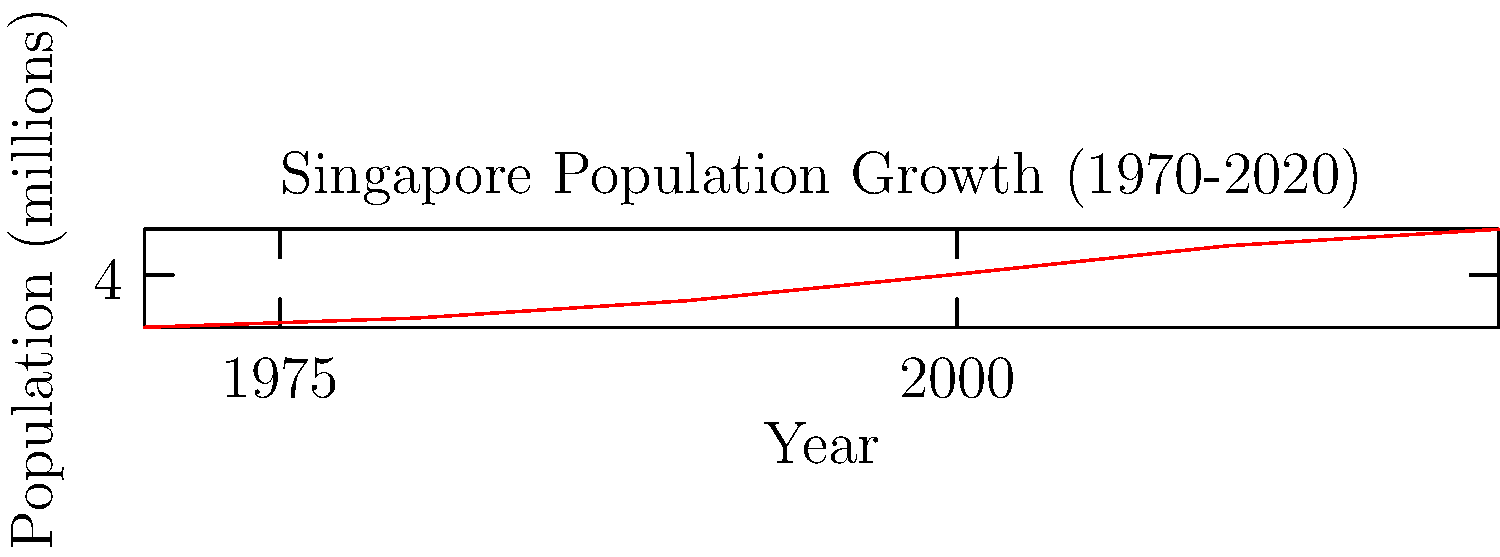Looking at the graph of Singapore's population growth from 1970 to 2020, in which decade did the population increase most rapidly? How does this relate to your experience living in Queenstown during that time? To determine the decade with the most rapid population growth, we need to calculate the population increase for each decade and compare:

1. 1970-1980: 2.41 - 2.07 = 0.34 million
2. 1980-1990: 3.05 - 2.41 = 0.64 million
3. 1990-2000: 4.03 - 3.05 = 0.98 million
4. 2000-2010: 5.08 - 4.03 = 1.05 million
5. 2010-2020: 5.69 - 5.08 = 0.61 million

The largest increase occurred between 2000 and 2010, with a growth of 1.05 million people.

For a long-time Singaporean citizen who lived in Queenstown but moved elsewhere for work decades ago, this rapid growth in the 2000s would have occurred after they had left. However, they would have experienced the significant growth in the 1990s (0.98 million increase) while still living in Queenstown, which may have contributed to increased housing demand and development in the area.
Answer: 2000-2010 